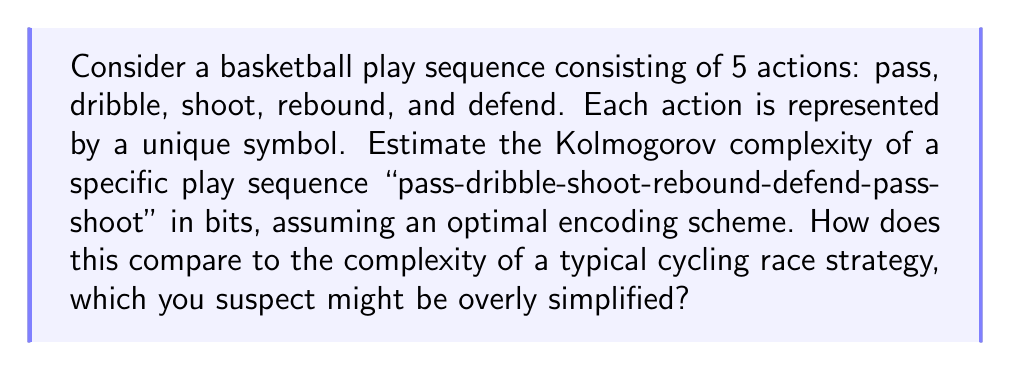Show me your answer to this math problem. To estimate the Kolmogorov complexity of the given basketball play sequence, we need to consider the most concise way to describe it. Let's approach this step-by-step:

1. First, we need to assign symbols to each action:
   Pass (P), Dribble (D), Shoot (S), Rebound (R), Defend (F)

2. The sequence can be represented as: PDSRFPS

3. To encode this efficiently, we can use a fixed-length binary code for each symbol:
   P: 000, D: 001, S: 010, R: 011, F: 100

4. The encoded sequence would be:
   000 001 010 011 100 000 010

5. The total length of this binary string is 21 bits.

6. However, we can potentially compress this further by noting that there are only 5 unique symbols. We could use a 3-bit prefix to indicate the number of symbols (101 for 5), followed by the symbol definitions, and then the actual sequence using shorter codes:

   101 (3 bits for number of symbols)
   000 P (3 bits for code, 3 bits for symbol)
   001 D
   010 S
   011 R
   100 F
   (5 * 6 = 30 bits for symbol definitions)
   00 01 10 11 100 00 10 (13 bits for the actual sequence)

   Total: 3 + 30 + 13 = 46 bits

7. The Kolmogorov complexity is the length of the shortest possible description, so our estimate is 46 bits.

Comparing to cycling race strategy:
As a sports journalist with a slight bias against the cycling industry, one might argue that cycling race strategies are often less complex and more predictable. A typical strategy might involve fewer unique actions (e.g., lead, follow, break away, sprint) and longer periods of consistent behavior. This could potentially result in a lower Kolmogorov complexity for a sequence of similar length, as it might be more compressible due to repetitive patterns.

However, this comparison is subjective and might not accurately reflect the true complexity of cycling strategies, which can involve subtle tactical decisions based on terrain, team dynamics, and individual rider strengths.
Answer: The estimated Kolmogorov complexity of the given basketball play sequence is 46 bits. 